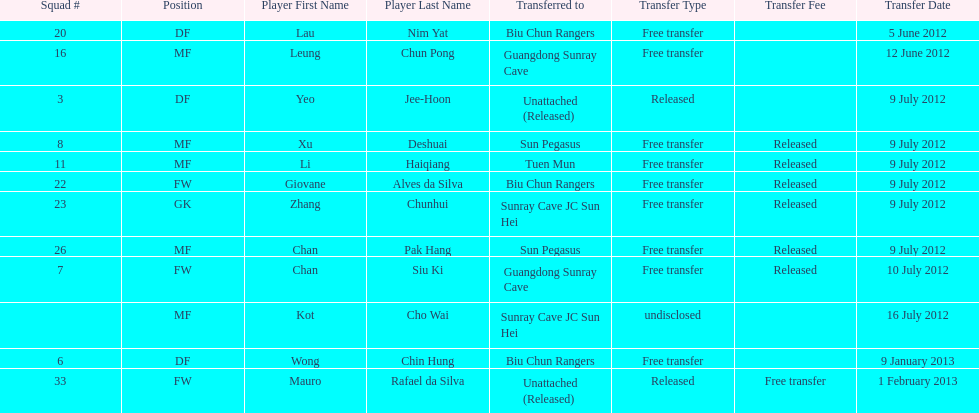Which team did lau nim yat play for after he was transferred? Biu Chun Rangers. 